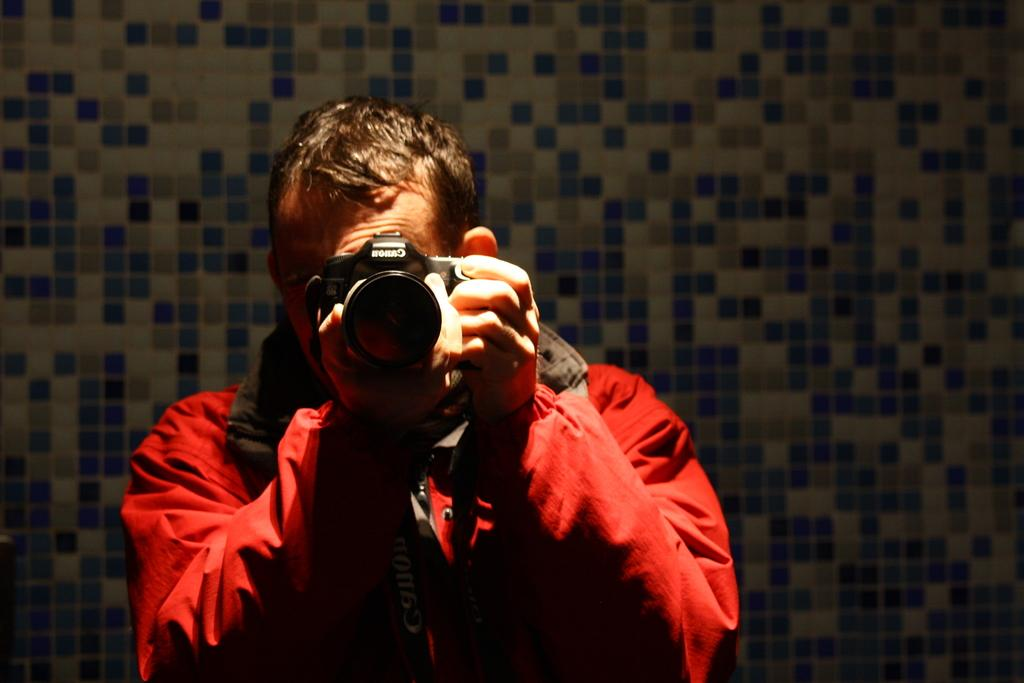What is the main subject of the image? There is a man in the image. What is the man wearing? The man is wearing a red jacket. What is the man holding in the image? The man is holding a camera. What type of nerve can be seen in the image? There is no nerve visible in the image; it features a man wearing a red jacket and holding a camera. What kind of sticks are being used by the man in the image? There are no sticks present in the image; the man is holding a camera. 